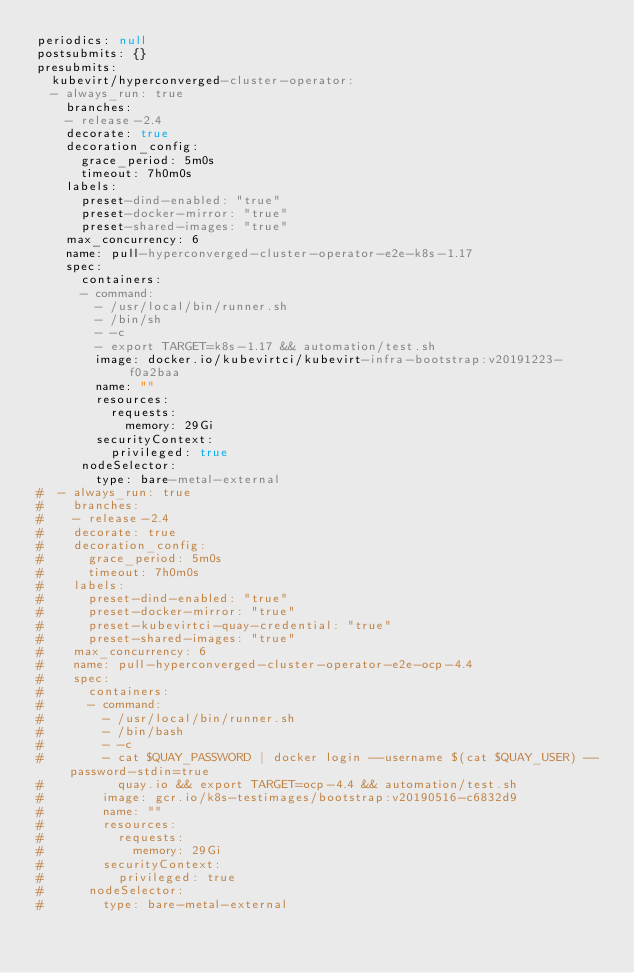<code> <loc_0><loc_0><loc_500><loc_500><_YAML_>periodics: null
postsubmits: {}
presubmits:
  kubevirt/hyperconverged-cluster-operator:
  - always_run: true
    branches:
    - release-2.4
    decorate: true
    decoration_config:
      grace_period: 5m0s
      timeout: 7h0m0s
    labels:
      preset-dind-enabled: "true"
      preset-docker-mirror: "true"
      preset-shared-images: "true"
    max_concurrency: 6
    name: pull-hyperconverged-cluster-operator-e2e-k8s-1.17
    spec:
      containers:
      - command:
        - /usr/local/bin/runner.sh
        - /bin/sh
        - -c
        - export TARGET=k8s-1.17 && automation/test.sh
        image: docker.io/kubevirtci/kubevirt-infra-bootstrap:v20191223-f0a2baa
        name: ""
        resources:
          requests:
            memory: 29Gi
        securityContext:
          privileged: true
      nodeSelector:
        type: bare-metal-external
#  - always_run: true
#    branches:
#    - release-2.4
#    decorate: true
#    decoration_config:
#      grace_period: 5m0s
#      timeout: 7h0m0s
#    labels:
#      preset-dind-enabled: "true"
#      preset-docker-mirror: "true"
#      preset-kubevirtci-quay-credential: "true"
#      preset-shared-images: "true"
#    max_concurrency: 6
#    name: pull-hyperconverged-cluster-operator-e2e-ocp-4.4
#    spec:
#      containers:
#      - command:
#        - /usr/local/bin/runner.sh
#        - /bin/bash
#        - -c
#        - cat $QUAY_PASSWORD | docker login --username $(cat $QUAY_USER) --password-stdin=true
#          quay.io && export TARGET=ocp-4.4 && automation/test.sh
#        image: gcr.io/k8s-testimages/bootstrap:v20190516-c6832d9
#        name: ""
#        resources:
#          requests:
#            memory: 29Gi
#        securityContext:
#          privileged: true
#      nodeSelector:
#        type: bare-metal-external
</code> 